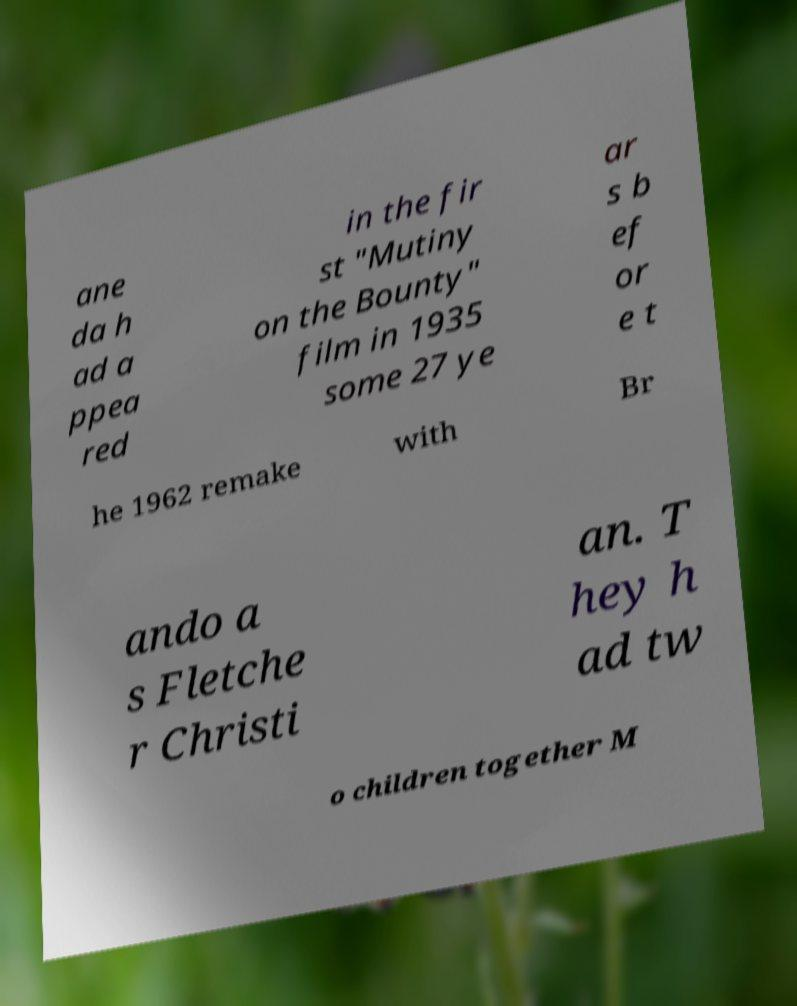Can you accurately transcribe the text from the provided image for me? ane da h ad a ppea red in the fir st "Mutiny on the Bounty" film in 1935 some 27 ye ar s b ef or e t he 1962 remake with Br ando a s Fletche r Christi an. T hey h ad tw o children together M 